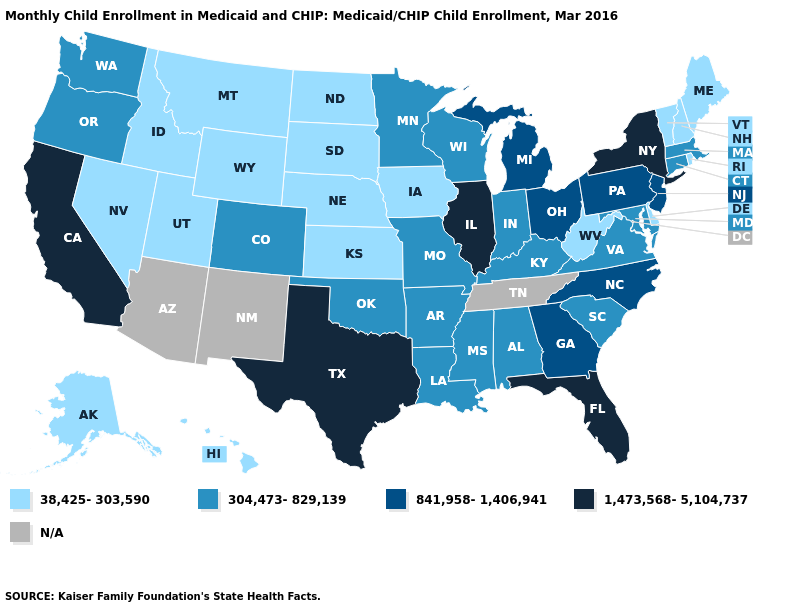Which states have the lowest value in the USA?
Short answer required. Alaska, Delaware, Hawaii, Idaho, Iowa, Kansas, Maine, Montana, Nebraska, Nevada, New Hampshire, North Dakota, Rhode Island, South Dakota, Utah, Vermont, West Virginia, Wyoming. Is the legend a continuous bar?
Write a very short answer. No. Among the states that border Wyoming , does Colorado have the highest value?
Quick response, please. Yes. Does West Virginia have the highest value in the USA?
Quick response, please. No. What is the value of Mississippi?
Write a very short answer. 304,473-829,139. What is the value of Alaska?
Write a very short answer. 38,425-303,590. Among the states that border Texas , which have the highest value?
Concise answer only. Arkansas, Louisiana, Oklahoma. What is the value of West Virginia?
Quick response, please. 38,425-303,590. What is the value of Illinois?
Concise answer only. 1,473,568-5,104,737. Name the states that have a value in the range 841,958-1,406,941?
Concise answer only. Georgia, Michigan, New Jersey, North Carolina, Ohio, Pennsylvania. Name the states that have a value in the range 1,473,568-5,104,737?
Keep it brief. California, Florida, Illinois, New York, Texas. What is the highest value in the West ?
Be succinct. 1,473,568-5,104,737. Does the map have missing data?
Concise answer only. Yes. 